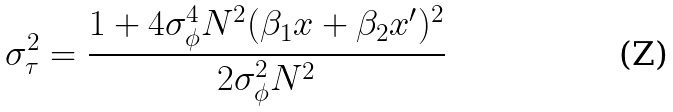<formula> <loc_0><loc_0><loc_500><loc_500>\sigma _ { \tau } ^ { 2 } = \frac { 1 + 4 \sigma _ { \phi } ^ { 4 } N ^ { 2 } ( \beta _ { 1 } x + \beta _ { 2 } x ^ { \prime } ) ^ { 2 } } { 2 \sigma _ { \phi } ^ { 2 } N ^ { 2 } }</formula> 